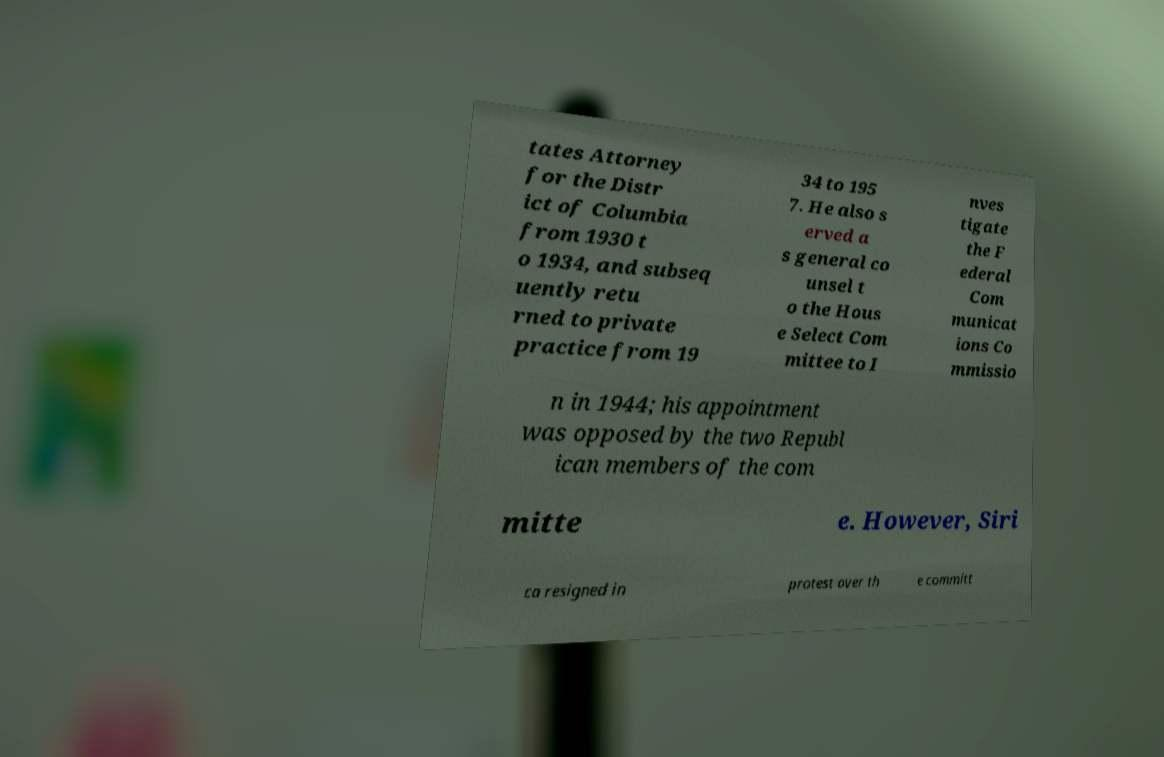Please read and relay the text visible in this image. What does it say? tates Attorney for the Distr ict of Columbia from 1930 t o 1934, and subseq uently retu rned to private practice from 19 34 to 195 7. He also s erved a s general co unsel t o the Hous e Select Com mittee to I nves tigate the F ederal Com municat ions Co mmissio n in 1944; his appointment was opposed by the two Republ ican members of the com mitte e. However, Siri ca resigned in protest over th e committ 